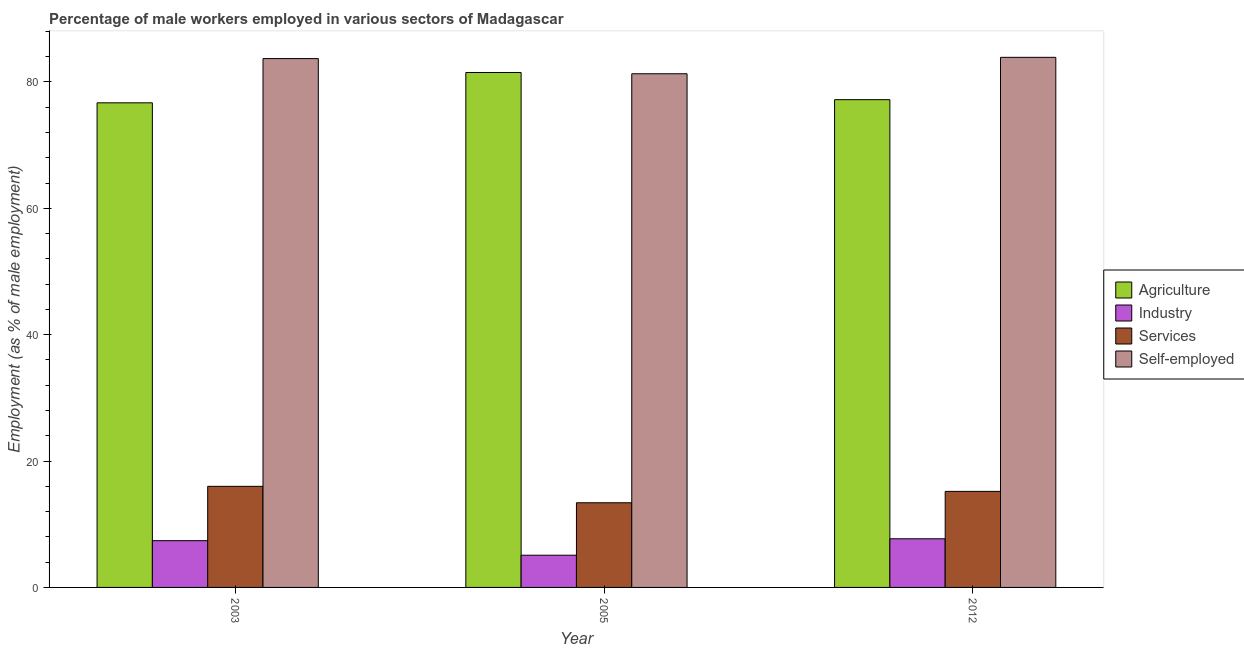How many different coloured bars are there?
Offer a terse response. 4. Are the number of bars per tick equal to the number of legend labels?
Ensure brevity in your answer.  Yes. How many bars are there on the 1st tick from the right?
Offer a very short reply. 4. What is the label of the 3rd group of bars from the left?
Provide a short and direct response. 2012. What is the percentage of male workers in industry in 2012?
Offer a terse response. 7.7. Across all years, what is the maximum percentage of self employed male workers?
Your answer should be very brief. 83.9. Across all years, what is the minimum percentage of male workers in agriculture?
Your response must be concise. 76.7. What is the total percentage of male workers in agriculture in the graph?
Keep it short and to the point. 235.4. What is the difference between the percentage of male workers in services in 2005 and that in 2012?
Offer a terse response. -1.8. What is the difference between the percentage of male workers in services in 2005 and the percentage of self employed male workers in 2012?
Your answer should be compact. -1.8. What is the average percentage of male workers in services per year?
Keep it short and to the point. 14.87. In the year 2005, what is the difference between the percentage of male workers in industry and percentage of self employed male workers?
Provide a short and direct response. 0. In how many years, is the percentage of male workers in agriculture greater than 80 %?
Give a very brief answer. 1. What is the ratio of the percentage of male workers in agriculture in 2003 to that in 2005?
Offer a very short reply. 0.94. What is the difference between the highest and the second highest percentage of male workers in agriculture?
Your response must be concise. 4.3. What is the difference between the highest and the lowest percentage of male workers in agriculture?
Your response must be concise. 4.8. Is it the case that in every year, the sum of the percentage of male workers in services and percentage of self employed male workers is greater than the sum of percentage of male workers in agriculture and percentage of male workers in industry?
Ensure brevity in your answer.  No. What does the 2nd bar from the left in 2005 represents?
Your answer should be compact. Industry. What does the 2nd bar from the right in 2012 represents?
Offer a very short reply. Services. Are all the bars in the graph horizontal?
Your answer should be very brief. No. What is the difference between two consecutive major ticks on the Y-axis?
Keep it short and to the point. 20. Does the graph contain grids?
Your answer should be compact. No. How many legend labels are there?
Give a very brief answer. 4. How are the legend labels stacked?
Provide a short and direct response. Vertical. What is the title of the graph?
Your response must be concise. Percentage of male workers employed in various sectors of Madagascar. Does "Tertiary education" appear as one of the legend labels in the graph?
Make the answer very short. No. What is the label or title of the Y-axis?
Ensure brevity in your answer.  Employment (as % of male employment). What is the Employment (as % of male employment) in Agriculture in 2003?
Make the answer very short. 76.7. What is the Employment (as % of male employment) in Industry in 2003?
Ensure brevity in your answer.  7.4. What is the Employment (as % of male employment) in Services in 2003?
Ensure brevity in your answer.  16. What is the Employment (as % of male employment) in Self-employed in 2003?
Provide a succinct answer. 83.7. What is the Employment (as % of male employment) in Agriculture in 2005?
Your response must be concise. 81.5. What is the Employment (as % of male employment) of Industry in 2005?
Offer a terse response. 5.1. What is the Employment (as % of male employment) in Services in 2005?
Your response must be concise. 13.4. What is the Employment (as % of male employment) of Self-employed in 2005?
Keep it short and to the point. 81.3. What is the Employment (as % of male employment) of Agriculture in 2012?
Offer a terse response. 77.2. What is the Employment (as % of male employment) in Industry in 2012?
Your answer should be compact. 7.7. What is the Employment (as % of male employment) of Services in 2012?
Provide a short and direct response. 15.2. What is the Employment (as % of male employment) of Self-employed in 2012?
Provide a short and direct response. 83.9. Across all years, what is the maximum Employment (as % of male employment) in Agriculture?
Ensure brevity in your answer.  81.5. Across all years, what is the maximum Employment (as % of male employment) of Industry?
Ensure brevity in your answer.  7.7. Across all years, what is the maximum Employment (as % of male employment) in Self-employed?
Provide a succinct answer. 83.9. Across all years, what is the minimum Employment (as % of male employment) in Agriculture?
Provide a succinct answer. 76.7. Across all years, what is the minimum Employment (as % of male employment) in Industry?
Make the answer very short. 5.1. Across all years, what is the minimum Employment (as % of male employment) in Services?
Give a very brief answer. 13.4. Across all years, what is the minimum Employment (as % of male employment) in Self-employed?
Provide a short and direct response. 81.3. What is the total Employment (as % of male employment) of Agriculture in the graph?
Offer a terse response. 235.4. What is the total Employment (as % of male employment) in Industry in the graph?
Offer a terse response. 20.2. What is the total Employment (as % of male employment) in Services in the graph?
Your answer should be compact. 44.6. What is the total Employment (as % of male employment) in Self-employed in the graph?
Make the answer very short. 248.9. What is the difference between the Employment (as % of male employment) of Agriculture in 2003 and that in 2005?
Keep it short and to the point. -4.8. What is the difference between the Employment (as % of male employment) in Services in 2003 and that in 2005?
Give a very brief answer. 2.6. What is the difference between the Employment (as % of male employment) of Agriculture in 2003 and that in 2012?
Ensure brevity in your answer.  -0.5. What is the difference between the Employment (as % of male employment) of Industry in 2003 and that in 2012?
Provide a short and direct response. -0.3. What is the difference between the Employment (as % of male employment) in Agriculture in 2005 and that in 2012?
Provide a short and direct response. 4.3. What is the difference between the Employment (as % of male employment) of Industry in 2005 and that in 2012?
Your response must be concise. -2.6. What is the difference between the Employment (as % of male employment) in Services in 2005 and that in 2012?
Give a very brief answer. -1.8. What is the difference between the Employment (as % of male employment) in Agriculture in 2003 and the Employment (as % of male employment) in Industry in 2005?
Offer a very short reply. 71.6. What is the difference between the Employment (as % of male employment) of Agriculture in 2003 and the Employment (as % of male employment) of Services in 2005?
Ensure brevity in your answer.  63.3. What is the difference between the Employment (as % of male employment) of Industry in 2003 and the Employment (as % of male employment) of Self-employed in 2005?
Your answer should be very brief. -73.9. What is the difference between the Employment (as % of male employment) in Services in 2003 and the Employment (as % of male employment) in Self-employed in 2005?
Offer a terse response. -65.3. What is the difference between the Employment (as % of male employment) in Agriculture in 2003 and the Employment (as % of male employment) in Services in 2012?
Make the answer very short. 61.5. What is the difference between the Employment (as % of male employment) of Industry in 2003 and the Employment (as % of male employment) of Self-employed in 2012?
Offer a terse response. -76.5. What is the difference between the Employment (as % of male employment) of Services in 2003 and the Employment (as % of male employment) of Self-employed in 2012?
Provide a succinct answer. -67.9. What is the difference between the Employment (as % of male employment) of Agriculture in 2005 and the Employment (as % of male employment) of Industry in 2012?
Keep it short and to the point. 73.8. What is the difference between the Employment (as % of male employment) in Agriculture in 2005 and the Employment (as % of male employment) in Services in 2012?
Keep it short and to the point. 66.3. What is the difference between the Employment (as % of male employment) of Agriculture in 2005 and the Employment (as % of male employment) of Self-employed in 2012?
Offer a very short reply. -2.4. What is the difference between the Employment (as % of male employment) in Industry in 2005 and the Employment (as % of male employment) in Self-employed in 2012?
Ensure brevity in your answer.  -78.8. What is the difference between the Employment (as % of male employment) of Services in 2005 and the Employment (as % of male employment) of Self-employed in 2012?
Ensure brevity in your answer.  -70.5. What is the average Employment (as % of male employment) in Agriculture per year?
Offer a terse response. 78.47. What is the average Employment (as % of male employment) in Industry per year?
Provide a succinct answer. 6.73. What is the average Employment (as % of male employment) of Services per year?
Your response must be concise. 14.87. What is the average Employment (as % of male employment) in Self-employed per year?
Offer a very short reply. 82.97. In the year 2003, what is the difference between the Employment (as % of male employment) in Agriculture and Employment (as % of male employment) in Industry?
Provide a succinct answer. 69.3. In the year 2003, what is the difference between the Employment (as % of male employment) of Agriculture and Employment (as % of male employment) of Services?
Ensure brevity in your answer.  60.7. In the year 2003, what is the difference between the Employment (as % of male employment) in Agriculture and Employment (as % of male employment) in Self-employed?
Your answer should be compact. -7. In the year 2003, what is the difference between the Employment (as % of male employment) in Industry and Employment (as % of male employment) in Self-employed?
Provide a short and direct response. -76.3. In the year 2003, what is the difference between the Employment (as % of male employment) of Services and Employment (as % of male employment) of Self-employed?
Keep it short and to the point. -67.7. In the year 2005, what is the difference between the Employment (as % of male employment) of Agriculture and Employment (as % of male employment) of Industry?
Offer a terse response. 76.4. In the year 2005, what is the difference between the Employment (as % of male employment) of Agriculture and Employment (as % of male employment) of Services?
Give a very brief answer. 68.1. In the year 2005, what is the difference between the Employment (as % of male employment) of Industry and Employment (as % of male employment) of Services?
Give a very brief answer. -8.3. In the year 2005, what is the difference between the Employment (as % of male employment) in Industry and Employment (as % of male employment) in Self-employed?
Make the answer very short. -76.2. In the year 2005, what is the difference between the Employment (as % of male employment) of Services and Employment (as % of male employment) of Self-employed?
Provide a succinct answer. -67.9. In the year 2012, what is the difference between the Employment (as % of male employment) of Agriculture and Employment (as % of male employment) of Industry?
Provide a succinct answer. 69.5. In the year 2012, what is the difference between the Employment (as % of male employment) in Industry and Employment (as % of male employment) in Self-employed?
Your answer should be compact. -76.2. In the year 2012, what is the difference between the Employment (as % of male employment) of Services and Employment (as % of male employment) of Self-employed?
Your answer should be very brief. -68.7. What is the ratio of the Employment (as % of male employment) in Agriculture in 2003 to that in 2005?
Keep it short and to the point. 0.94. What is the ratio of the Employment (as % of male employment) in Industry in 2003 to that in 2005?
Ensure brevity in your answer.  1.45. What is the ratio of the Employment (as % of male employment) of Services in 2003 to that in 2005?
Your answer should be very brief. 1.19. What is the ratio of the Employment (as % of male employment) in Self-employed in 2003 to that in 2005?
Provide a short and direct response. 1.03. What is the ratio of the Employment (as % of male employment) in Services in 2003 to that in 2012?
Offer a terse response. 1.05. What is the ratio of the Employment (as % of male employment) of Agriculture in 2005 to that in 2012?
Your response must be concise. 1.06. What is the ratio of the Employment (as % of male employment) in Industry in 2005 to that in 2012?
Offer a terse response. 0.66. What is the ratio of the Employment (as % of male employment) of Services in 2005 to that in 2012?
Your answer should be very brief. 0.88. What is the difference between the highest and the second highest Employment (as % of male employment) in Agriculture?
Offer a terse response. 4.3. What is the difference between the highest and the second highest Employment (as % of male employment) in Services?
Provide a succinct answer. 0.8. What is the difference between the highest and the second highest Employment (as % of male employment) of Self-employed?
Provide a short and direct response. 0.2. What is the difference between the highest and the lowest Employment (as % of male employment) in Industry?
Offer a terse response. 2.6. 